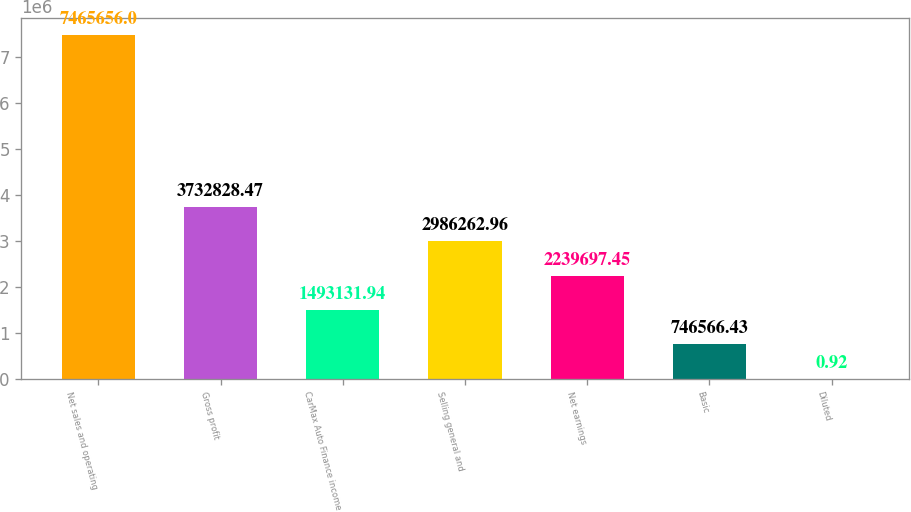<chart> <loc_0><loc_0><loc_500><loc_500><bar_chart><fcel>Net sales and operating<fcel>Gross profit<fcel>CarMax Auto Finance income<fcel>Selling general and<fcel>Net earnings<fcel>Basic<fcel>Diluted<nl><fcel>7.46566e+06<fcel>3.73283e+06<fcel>1.49313e+06<fcel>2.98626e+06<fcel>2.2397e+06<fcel>746566<fcel>0.92<nl></chart> 